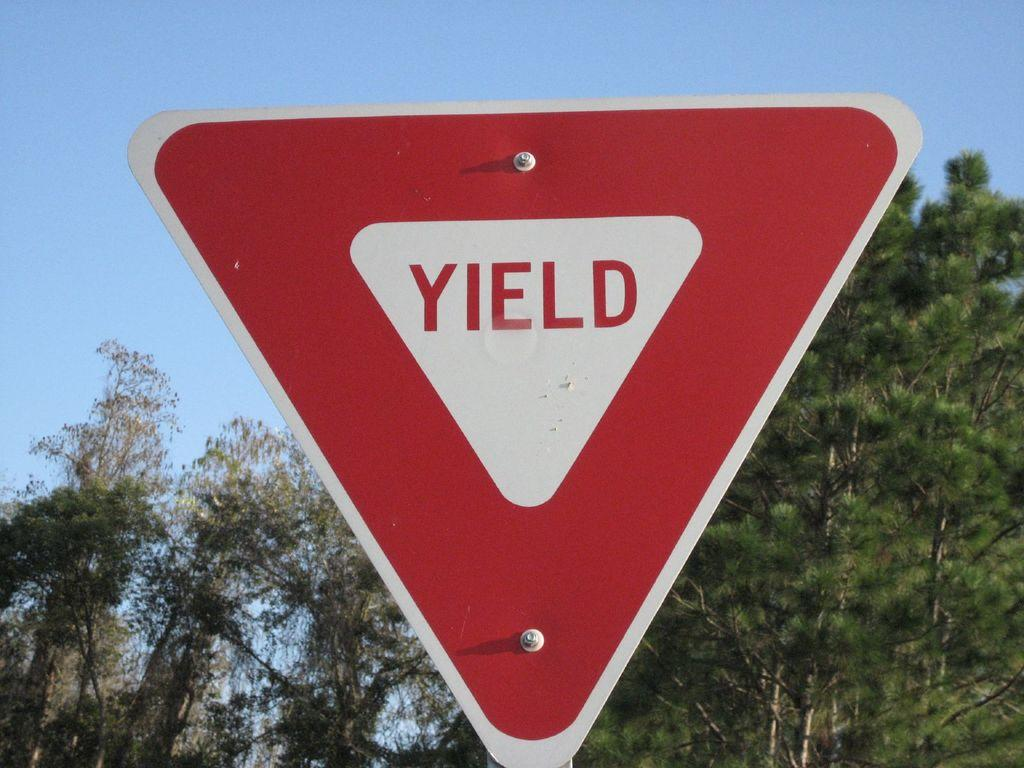Provide a one-sentence caption for the provided image. Red and white Yield sign in front of some trees. 